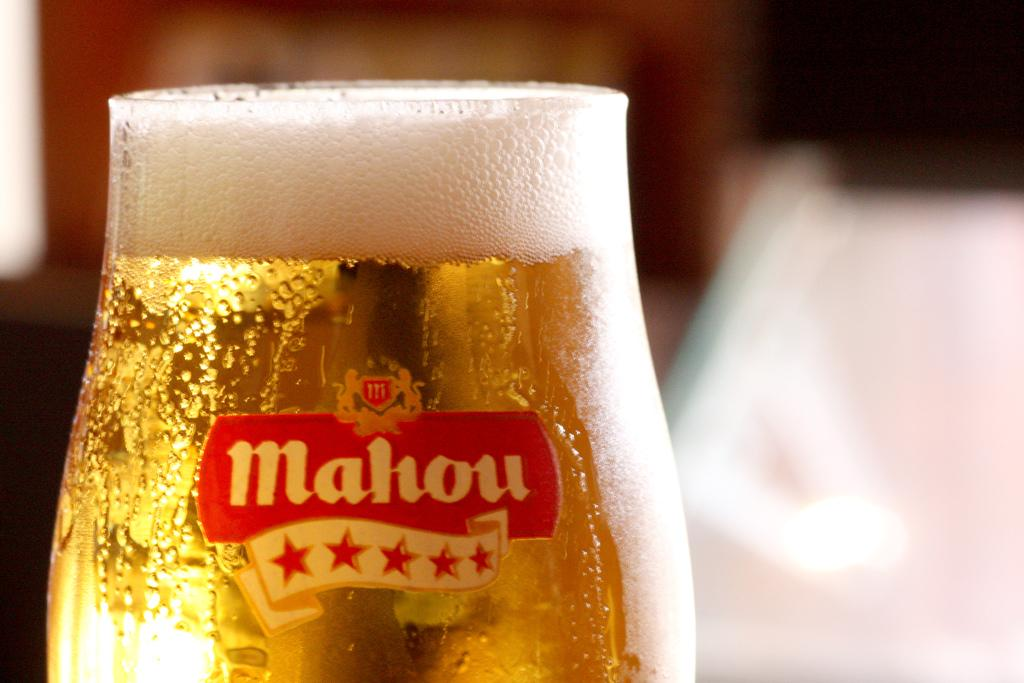<image>
Share a concise interpretation of the image provided. A freshly poured glass of Mahou beer filled with foam in glass in on a table. 